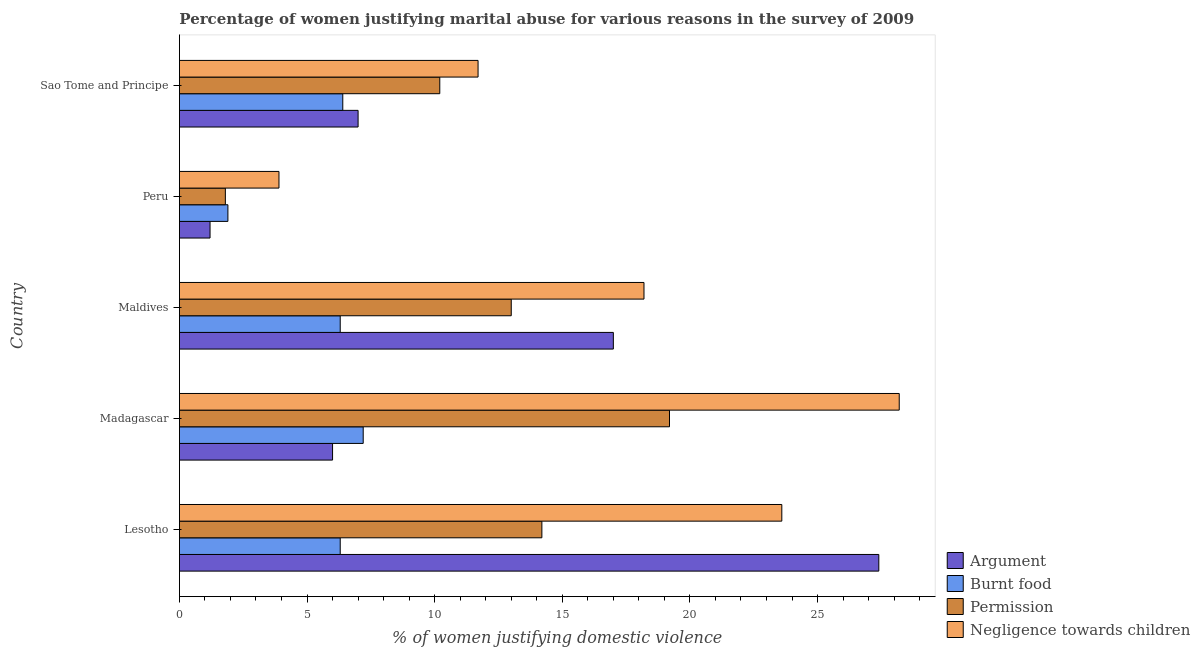How many bars are there on the 4th tick from the top?
Ensure brevity in your answer.  4. How many bars are there on the 4th tick from the bottom?
Provide a short and direct response. 4. What is the label of the 2nd group of bars from the top?
Provide a succinct answer. Peru. In how many cases, is the number of bars for a given country not equal to the number of legend labels?
Provide a succinct answer. 0. What is the percentage of women justifying abuse for showing negligence towards children in Sao Tome and Principe?
Ensure brevity in your answer.  11.7. Across all countries, what is the minimum percentage of women justifying abuse in the case of an argument?
Offer a terse response. 1.2. In which country was the percentage of women justifying abuse for showing negligence towards children maximum?
Your answer should be compact. Madagascar. What is the total percentage of women justifying abuse for showing negligence towards children in the graph?
Your response must be concise. 85.6. What is the average percentage of women justifying abuse for burning food per country?
Provide a succinct answer. 5.62. In how many countries, is the percentage of women justifying abuse for going without permission greater than 27 %?
Offer a terse response. 0. What is the ratio of the percentage of women justifying abuse in the case of an argument in Madagascar to that in Sao Tome and Principe?
Ensure brevity in your answer.  0.86. What is the difference between the highest and the second highest percentage of women justifying abuse for going without permission?
Your response must be concise. 5. What is the difference between the highest and the lowest percentage of women justifying abuse in the case of an argument?
Keep it short and to the point. 26.2. In how many countries, is the percentage of women justifying abuse for burning food greater than the average percentage of women justifying abuse for burning food taken over all countries?
Offer a terse response. 4. Is the sum of the percentage of women justifying abuse for going without permission in Maldives and Peru greater than the maximum percentage of women justifying abuse for showing negligence towards children across all countries?
Your answer should be very brief. No. What does the 3rd bar from the top in Peru represents?
Your response must be concise. Burnt food. What does the 2nd bar from the bottom in Sao Tome and Principe represents?
Offer a very short reply. Burnt food. Is it the case that in every country, the sum of the percentage of women justifying abuse in the case of an argument and percentage of women justifying abuse for burning food is greater than the percentage of women justifying abuse for going without permission?
Offer a very short reply. No. How many bars are there?
Ensure brevity in your answer.  20. Are all the bars in the graph horizontal?
Offer a very short reply. Yes. How many countries are there in the graph?
Keep it short and to the point. 5. Does the graph contain any zero values?
Keep it short and to the point. No. Where does the legend appear in the graph?
Make the answer very short. Bottom right. How many legend labels are there?
Offer a terse response. 4. How are the legend labels stacked?
Make the answer very short. Vertical. What is the title of the graph?
Provide a succinct answer. Percentage of women justifying marital abuse for various reasons in the survey of 2009. What is the label or title of the X-axis?
Ensure brevity in your answer.  % of women justifying domestic violence. What is the % of women justifying domestic violence in Argument in Lesotho?
Offer a very short reply. 27.4. What is the % of women justifying domestic violence in Burnt food in Lesotho?
Provide a succinct answer. 6.3. What is the % of women justifying domestic violence of Negligence towards children in Lesotho?
Offer a very short reply. 23.6. What is the % of women justifying domestic violence in Burnt food in Madagascar?
Provide a succinct answer. 7.2. What is the % of women justifying domestic violence of Negligence towards children in Madagascar?
Give a very brief answer. 28.2. What is the % of women justifying domestic violence of Burnt food in Maldives?
Your response must be concise. 6.3. What is the % of women justifying domestic violence of Argument in Peru?
Provide a succinct answer. 1.2. What is the % of women justifying domestic violence in Permission in Peru?
Give a very brief answer. 1.8. What is the % of women justifying domestic violence in Argument in Sao Tome and Principe?
Your answer should be very brief. 7. What is the % of women justifying domestic violence in Burnt food in Sao Tome and Principe?
Provide a succinct answer. 6.4. What is the % of women justifying domestic violence of Permission in Sao Tome and Principe?
Ensure brevity in your answer.  10.2. Across all countries, what is the maximum % of women justifying domestic violence in Argument?
Your answer should be compact. 27.4. Across all countries, what is the maximum % of women justifying domestic violence in Burnt food?
Make the answer very short. 7.2. Across all countries, what is the maximum % of women justifying domestic violence of Permission?
Provide a short and direct response. 19.2. Across all countries, what is the maximum % of women justifying domestic violence in Negligence towards children?
Provide a succinct answer. 28.2. Across all countries, what is the minimum % of women justifying domestic violence of Burnt food?
Provide a succinct answer. 1.9. What is the total % of women justifying domestic violence in Argument in the graph?
Your response must be concise. 58.6. What is the total % of women justifying domestic violence of Burnt food in the graph?
Provide a succinct answer. 28.1. What is the total % of women justifying domestic violence in Permission in the graph?
Your answer should be compact. 58.4. What is the total % of women justifying domestic violence of Negligence towards children in the graph?
Provide a short and direct response. 85.6. What is the difference between the % of women justifying domestic violence in Argument in Lesotho and that in Madagascar?
Give a very brief answer. 21.4. What is the difference between the % of women justifying domestic violence of Burnt food in Lesotho and that in Madagascar?
Ensure brevity in your answer.  -0.9. What is the difference between the % of women justifying domestic violence in Negligence towards children in Lesotho and that in Madagascar?
Ensure brevity in your answer.  -4.6. What is the difference between the % of women justifying domestic violence in Burnt food in Lesotho and that in Maldives?
Give a very brief answer. 0. What is the difference between the % of women justifying domestic violence of Permission in Lesotho and that in Maldives?
Provide a succinct answer. 1.2. What is the difference between the % of women justifying domestic violence of Argument in Lesotho and that in Peru?
Ensure brevity in your answer.  26.2. What is the difference between the % of women justifying domestic violence in Negligence towards children in Lesotho and that in Peru?
Keep it short and to the point. 19.7. What is the difference between the % of women justifying domestic violence of Argument in Lesotho and that in Sao Tome and Principe?
Give a very brief answer. 20.4. What is the difference between the % of women justifying domestic violence in Permission in Lesotho and that in Sao Tome and Principe?
Your answer should be compact. 4. What is the difference between the % of women justifying domestic violence of Burnt food in Madagascar and that in Maldives?
Offer a very short reply. 0.9. What is the difference between the % of women justifying domestic violence of Argument in Madagascar and that in Peru?
Your response must be concise. 4.8. What is the difference between the % of women justifying domestic violence of Burnt food in Madagascar and that in Peru?
Keep it short and to the point. 5.3. What is the difference between the % of women justifying domestic violence in Negligence towards children in Madagascar and that in Peru?
Offer a terse response. 24.3. What is the difference between the % of women justifying domestic violence of Argument in Madagascar and that in Sao Tome and Principe?
Ensure brevity in your answer.  -1. What is the difference between the % of women justifying domestic violence of Argument in Maldives and that in Peru?
Your response must be concise. 15.8. What is the difference between the % of women justifying domestic violence in Burnt food in Maldives and that in Peru?
Offer a very short reply. 4.4. What is the difference between the % of women justifying domestic violence in Permission in Maldives and that in Peru?
Keep it short and to the point. 11.2. What is the difference between the % of women justifying domestic violence in Negligence towards children in Maldives and that in Sao Tome and Principe?
Provide a succinct answer. 6.5. What is the difference between the % of women justifying domestic violence of Argument in Peru and that in Sao Tome and Principe?
Your answer should be compact. -5.8. What is the difference between the % of women justifying domestic violence in Burnt food in Peru and that in Sao Tome and Principe?
Give a very brief answer. -4.5. What is the difference between the % of women justifying domestic violence in Argument in Lesotho and the % of women justifying domestic violence in Burnt food in Madagascar?
Keep it short and to the point. 20.2. What is the difference between the % of women justifying domestic violence of Argument in Lesotho and the % of women justifying domestic violence of Permission in Madagascar?
Make the answer very short. 8.2. What is the difference between the % of women justifying domestic violence in Argument in Lesotho and the % of women justifying domestic violence in Negligence towards children in Madagascar?
Give a very brief answer. -0.8. What is the difference between the % of women justifying domestic violence in Burnt food in Lesotho and the % of women justifying domestic violence in Negligence towards children in Madagascar?
Your answer should be compact. -21.9. What is the difference between the % of women justifying domestic violence in Argument in Lesotho and the % of women justifying domestic violence in Burnt food in Maldives?
Your answer should be compact. 21.1. What is the difference between the % of women justifying domestic violence of Argument in Lesotho and the % of women justifying domestic violence of Permission in Maldives?
Make the answer very short. 14.4. What is the difference between the % of women justifying domestic violence in Argument in Lesotho and the % of women justifying domestic violence in Negligence towards children in Maldives?
Ensure brevity in your answer.  9.2. What is the difference between the % of women justifying domestic violence of Burnt food in Lesotho and the % of women justifying domestic violence of Permission in Maldives?
Make the answer very short. -6.7. What is the difference between the % of women justifying domestic violence of Burnt food in Lesotho and the % of women justifying domestic violence of Negligence towards children in Maldives?
Make the answer very short. -11.9. What is the difference between the % of women justifying domestic violence of Permission in Lesotho and the % of women justifying domestic violence of Negligence towards children in Maldives?
Offer a very short reply. -4. What is the difference between the % of women justifying domestic violence of Argument in Lesotho and the % of women justifying domestic violence of Permission in Peru?
Offer a terse response. 25.6. What is the difference between the % of women justifying domestic violence in Burnt food in Lesotho and the % of women justifying domestic violence in Permission in Peru?
Your answer should be very brief. 4.5. What is the difference between the % of women justifying domestic violence in Permission in Lesotho and the % of women justifying domestic violence in Negligence towards children in Peru?
Offer a terse response. 10.3. What is the difference between the % of women justifying domestic violence in Burnt food in Lesotho and the % of women justifying domestic violence in Permission in Sao Tome and Principe?
Your answer should be compact. -3.9. What is the difference between the % of women justifying domestic violence of Burnt food in Lesotho and the % of women justifying domestic violence of Negligence towards children in Sao Tome and Principe?
Give a very brief answer. -5.4. What is the difference between the % of women justifying domestic violence of Argument in Madagascar and the % of women justifying domestic violence of Permission in Peru?
Your answer should be very brief. 4.2. What is the difference between the % of women justifying domestic violence in Argument in Madagascar and the % of women justifying domestic violence in Negligence towards children in Peru?
Make the answer very short. 2.1. What is the difference between the % of women justifying domestic violence in Burnt food in Madagascar and the % of women justifying domestic violence in Permission in Peru?
Make the answer very short. 5.4. What is the difference between the % of women justifying domestic violence in Burnt food in Madagascar and the % of women justifying domestic violence in Negligence towards children in Peru?
Your response must be concise. 3.3. What is the difference between the % of women justifying domestic violence of Argument in Madagascar and the % of women justifying domestic violence of Permission in Sao Tome and Principe?
Give a very brief answer. -4.2. What is the difference between the % of women justifying domestic violence in Burnt food in Madagascar and the % of women justifying domestic violence in Negligence towards children in Sao Tome and Principe?
Your response must be concise. -4.5. What is the difference between the % of women justifying domestic violence in Permission in Madagascar and the % of women justifying domestic violence in Negligence towards children in Sao Tome and Principe?
Make the answer very short. 7.5. What is the difference between the % of women justifying domestic violence in Argument in Maldives and the % of women justifying domestic violence in Permission in Peru?
Make the answer very short. 15.2. What is the difference between the % of women justifying domestic violence in Argument in Maldives and the % of women justifying domestic violence in Negligence towards children in Peru?
Ensure brevity in your answer.  13.1. What is the difference between the % of women justifying domestic violence in Permission in Maldives and the % of women justifying domestic violence in Negligence towards children in Peru?
Ensure brevity in your answer.  9.1. What is the difference between the % of women justifying domestic violence in Argument in Maldives and the % of women justifying domestic violence in Burnt food in Sao Tome and Principe?
Give a very brief answer. 10.6. What is the difference between the % of women justifying domestic violence of Burnt food in Maldives and the % of women justifying domestic violence of Permission in Sao Tome and Principe?
Offer a terse response. -3.9. What is the difference between the % of women justifying domestic violence in Argument in Peru and the % of women justifying domestic violence in Negligence towards children in Sao Tome and Principe?
Offer a very short reply. -10.5. What is the average % of women justifying domestic violence of Argument per country?
Provide a succinct answer. 11.72. What is the average % of women justifying domestic violence of Burnt food per country?
Your answer should be compact. 5.62. What is the average % of women justifying domestic violence of Permission per country?
Provide a succinct answer. 11.68. What is the average % of women justifying domestic violence in Negligence towards children per country?
Provide a succinct answer. 17.12. What is the difference between the % of women justifying domestic violence in Argument and % of women justifying domestic violence in Burnt food in Lesotho?
Ensure brevity in your answer.  21.1. What is the difference between the % of women justifying domestic violence in Argument and % of women justifying domestic violence in Negligence towards children in Lesotho?
Your answer should be very brief. 3.8. What is the difference between the % of women justifying domestic violence in Burnt food and % of women justifying domestic violence in Negligence towards children in Lesotho?
Your answer should be very brief. -17.3. What is the difference between the % of women justifying domestic violence in Permission and % of women justifying domestic violence in Negligence towards children in Lesotho?
Provide a short and direct response. -9.4. What is the difference between the % of women justifying domestic violence of Argument and % of women justifying domestic violence of Negligence towards children in Madagascar?
Your answer should be very brief. -22.2. What is the difference between the % of women justifying domestic violence of Argument and % of women justifying domestic violence of Burnt food in Maldives?
Provide a succinct answer. 10.7. What is the difference between the % of women justifying domestic violence in Argument and % of women justifying domestic violence in Permission in Maldives?
Provide a succinct answer. 4. What is the difference between the % of women justifying domestic violence in Burnt food and % of women justifying domestic violence in Permission in Maldives?
Your response must be concise. -6.7. What is the difference between the % of women justifying domestic violence of Burnt food and % of women justifying domestic violence of Negligence towards children in Maldives?
Give a very brief answer. -11.9. What is the difference between the % of women justifying domestic violence in Argument and % of women justifying domestic violence in Burnt food in Peru?
Offer a very short reply. -0.7. What is the difference between the % of women justifying domestic violence in Permission and % of women justifying domestic violence in Negligence towards children in Peru?
Offer a very short reply. -2.1. What is the difference between the % of women justifying domestic violence in Argument and % of women justifying domestic violence in Burnt food in Sao Tome and Principe?
Offer a very short reply. 0.6. What is the difference between the % of women justifying domestic violence of Argument and % of women justifying domestic violence of Negligence towards children in Sao Tome and Principe?
Provide a succinct answer. -4.7. What is the difference between the % of women justifying domestic violence in Burnt food and % of women justifying domestic violence in Permission in Sao Tome and Principe?
Provide a short and direct response. -3.8. What is the difference between the % of women justifying domestic violence of Burnt food and % of women justifying domestic violence of Negligence towards children in Sao Tome and Principe?
Your answer should be compact. -5.3. What is the difference between the % of women justifying domestic violence in Permission and % of women justifying domestic violence in Negligence towards children in Sao Tome and Principe?
Provide a short and direct response. -1.5. What is the ratio of the % of women justifying domestic violence of Argument in Lesotho to that in Madagascar?
Give a very brief answer. 4.57. What is the ratio of the % of women justifying domestic violence of Burnt food in Lesotho to that in Madagascar?
Make the answer very short. 0.88. What is the ratio of the % of women justifying domestic violence in Permission in Lesotho to that in Madagascar?
Your response must be concise. 0.74. What is the ratio of the % of women justifying domestic violence in Negligence towards children in Lesotho to that in Madagascar?
Offer a very short reply. 0.84. What is the ratio of the % of women justifying domestic violence of Argument in Lesotho to that in Maldives?
Give a very brief answer. 1.61. What is the ratio of the % of women justifying domestic violence in Burnt food in Lesotho to that in Maldives?
Make the answer very short. 1. What is the ratio of the % of women justifying domestic violence in Permission in Lesotho to that in Maldives?
Your answer should be compact. 1.09. What is the ratio of the % of women justifying domestic violence of Negligence towards children in Lesotho to that in Maldives?
Offer a very short reply. 1.3. What is the ratio of the % of women justifying domestic violence in Argument in Lesotho to that in Peru?
Give a very brief answer. 22.83. What is the ratio of the % of women justifying domestic violence of Burnt food in Lesotho to that in Peru?
Provide a short and direct response. 3.32. What is the ratio of the % of women justifying domestic violence in Permission in Lesotho to that in Peru?
Ensure brevity in your answer.  7.89. What is the ratio of the % of women justifying domestic violence in Negligence towards children in Lesotho to that in Peru?
Provide a short and direct response. 6.05. What is the ratio of the % of women justifying domestic violence in Argument in Lesotho to that in Sao Tome and Principe?
Make the answer very short. 3.91. What is the ratio of the % of women justifying domestic violence in Burnt food in Lesotho to that in Sao Tome and Principe?
Ensure brevity in your answer.  0.98. What is the ratio of the % of women justifying domestic violence of Permission in Lesotho to that in Sao Tome and Principe?
Provide a short and direct response. 1.39. What is the ratio of the % of women justifying domestic violence in Negligence towards children in Lesotho to that in Sao Tome and Principe?
Offer a very short reply. 2.02. What is the ratio of the % of women justifying domestic violence in Argument in Madagascar to that in Maldives?
Your response must be concise. 0.35. What is the ratio of the % of women justifying domestic violence of Burnt food in Madagascar to that in Maldives?
Offer a terse response. 1.14. What is the ratio of the % of women justifying domestic violence of Permission in Madagascar to that in Maldives?
Provide a short and direct response. 1.48. What is the ratio of the % of women justifying domestic violence of Negligence towards children in Madagascar to that in Maldives?
Provide a short and direct response. 1.55. What is the ratio of the % of women justifying domestic violence of Argument in Madagascar to that in Peru?
Keep it short and to the point. 5. What is the ratio of the % of women justifying domestic violence of Burnt food in Madagascar to that in Peru?
Make the answer very short. 3.79. What is the ratio of the % of women justifying domestic violence of Permission in Madagascar to that in Peru?
Keep it short and to the point. 10.67. What is the ratio of the % of women justifying domestic violence of Negligence towards children in Madagascar to that in Peru?
Give a very brief answer. 7.23. What is the ratio of the % of women justifying domestic violence of Permission in Madagascar to that in Sao Tome and Principe?
Provide a succinct answer. 1.88. What is the ratio of the % of women justifying domestic violence of Negligence towards children in Madagascar to that in Sao Tome and Principe?
Offer a very short reply. 2.41. What is the ratio of the % of women justifying domestic violence in Argument in Maldives to that in Peru?
Your answer should be compact. 14.17. What is the ratio of the % of women justifying domestic violence in Burnt food in Maldives to that in Peru?
Your answer should be compact. 3.32. What is the ratio of the % of women justifying domestic violence of Permission in Maldives to that in Peru?
Ensure brevity in your answer.  7.22. What is the ratio of the % of women justifying domestic violence of Negligence towards children in Maldives to that in Peru?
Offer a very short reply. 4.67. What is the ratio of the % of women justifying domestic violence in Argument in Maldives to that in Sao Tome and Principe?
Ensure brevity in your answer.  2.43. What is the ratio of the % of women justifying domestic violence of Burnt food in Maldives to that in Sao Tome and Principe?
Make the answer very short. 0.98. What is the ratio of the % of women justifying domestic violence of Permission in Maldives to that in Sao Tome and Principe?
Offer a very short reply. 1.27. What is the ratio of the % of women justifying domestic violence of Negligence towards children in Maldives to that in Sao Tome and Principe?
Provide a succinct answer. 1.56. What is the ratio of the % of women justifying domestic violence in Argument in Peru to that in Sao Tome and Principe?
Offer a very short reply. 0.17. What is the ratio of the % of women justifying domestic violence of Burnt food in Peru to that in Sao Tome and Principe?
Your response must be concise. 0.3. What is the ratio of the % of women justifying domestic violence in Permission in Peru to that in Sao Tome and Principe?
Give a very brief answer. 0.18. What is the difference between the highest and the lowest % of women justifying domestic violence of Argument?
Your answer should be compact. 26.2. What is the difference between the highest and the lowest % of women justifying domestic violence of Permission?
Ensure brevity in your answer.  17.4. What is the difference between the highest and the lowest % of women justifying domestic violence in Negligence towards children?
Give a very brief answer. 24.3. 